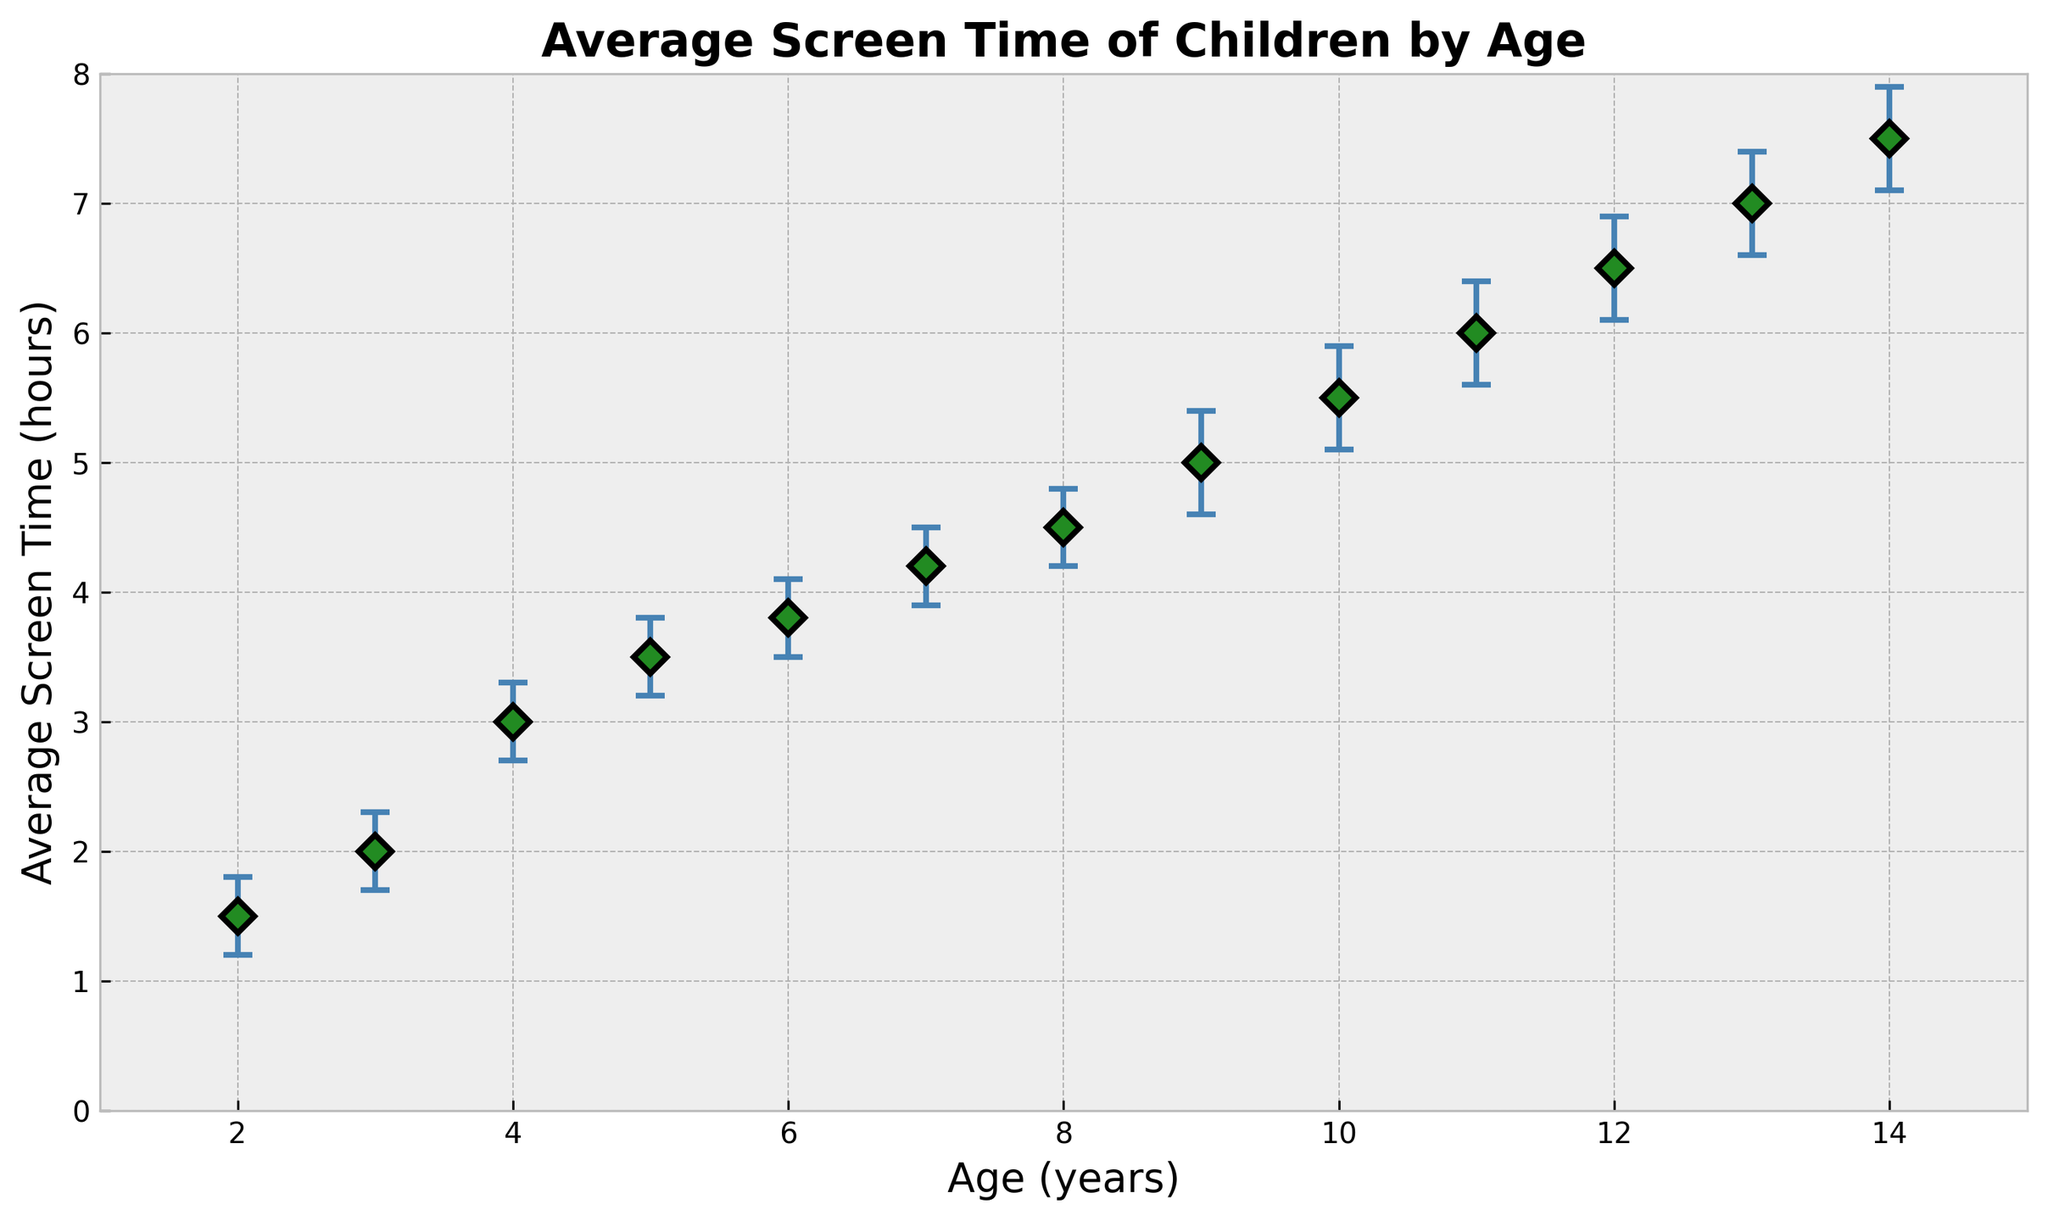Which age group has the highest average screen time? The figure shows the average screen time by age. The highest average screen time is seen at age 14, indicated by the topmost data point on the vertical axis.
Answer: 14 What is the average screen time for children aged 7? Locate the point on the plot corresponding to age 7. The average screen time for this age group is 4.2 hours.
Answer: 4.2 hours What is the confidence interval for the average screen time of children aged 10? Locate the point at age 10 and its error bars. The lower bound is 5.1 hours, and the upper bound is 5.9 hours.
Answer: 5.1 to 5.9 hours How does the average screen time for children aged 8 compare with those aged 5? Compare the points at ages 8 and 5 on the plot. The average screen time for age 8 is 4.5 hours, while for age 5, it is 3.5 hours.
Answer: 1 hour more Which age group has the smallest confidence interval width? Calculate the confidence interval width for each age group by subtracting the lower bound from the upper bound. The smallest width is for age 2 (1.8 - 1.2 = 0.6 hours).
Answer: Age 2 How much does the average screen time increase from age 6 to age 9? Subtract the average screen time at age 6 (3.8 hours) from the average screen time at age 9 (5.0 hours).
Answer: 1.2 hours Which age group has a confidence interval that overlaps with age 4’s average screen time? The average screen time for age 4 is 3.0 hours, with a confidence interval from 2.7 to 3.3 hours. Overlapping intervals include ages 5 and 6.
Answer: Ages 5 and 6 What is the range of the average screen times shown in the figure? The minimum and maximum points on the plot indicate the range. The minimum is 1.5 hours (age 2), and the maximum is 7.5 hours (age 14).
Answer: 1.5 to 7.5 hours How does the overall trend of screen time by age appear in the figure? The points and their connecting error bars show a general upward trend as age increases, indicating that older children tend to have more screen time.
Answer: Increasing trend What’s the difference between the confidence interval upper bounds for ages 11 and 13? Locate the upper bounds at ages 11 (6.4 hours) and 13 (7.4 hours) and subtract the smaller number from the larger.
Answer: 1 hour 